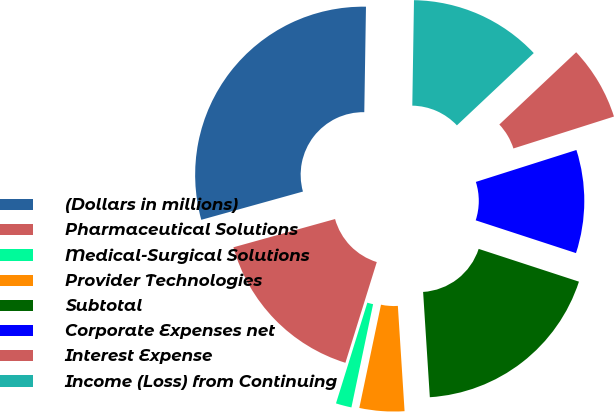Convert chart to OTSL. <chart><loc_0><loc_0><loc_500><loc_500><pie_chart><fcel>(Dollars in millions)<fcel>Pharmaceutical Solutions<fcel>Medical-Surgical Solutions<fcel>Provider Technologies<fcel>Subtotal<fcel>Corporate Expenses net<fcel>Interest Expense<fcel>Income (Loss) from Continuing<nl><fcel>29.57%<fcel>15.88%<fcel>1.51%<fcel>4.31%<fcel>18.96%<fcel>9.92%<fcel>7.12%<fcel>12.73%<nl></chart> 